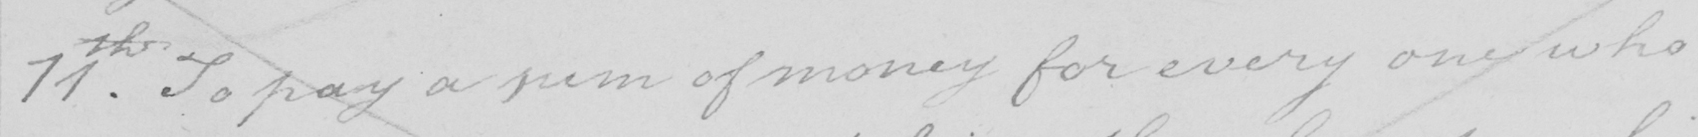What does this handwritten line say? 11th . To pay a sum of money for every one who 